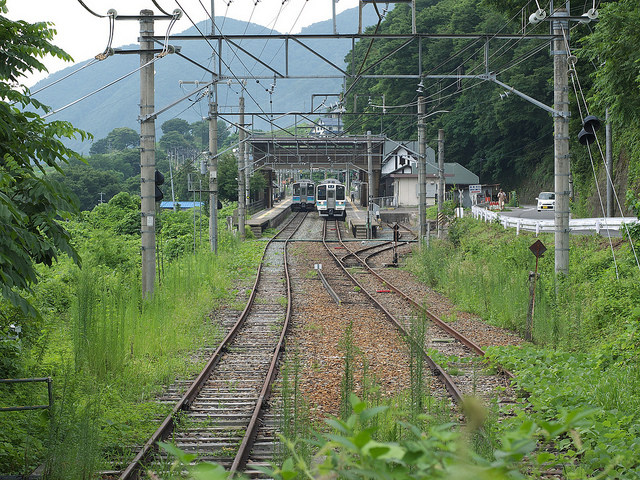How many trains could be traveling underneath of these wires overhanging the train track?
A. three
B. two
C. five
D. four The correct answer is B, two. The image displays two sets of tracks with one train on each, positioned under an extensive network of overhead electrical wires that provide power to these electrically-operated trains. 